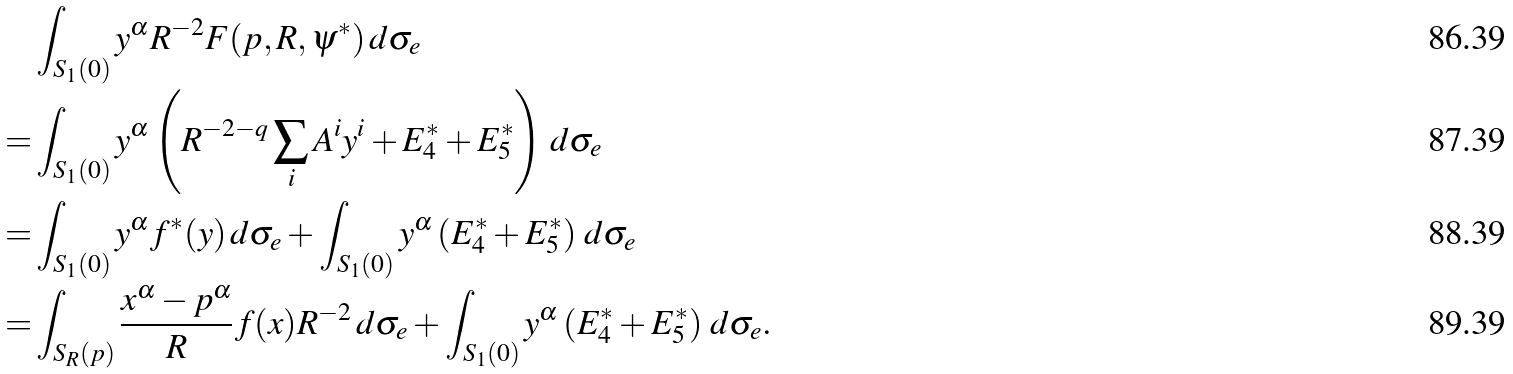<formula> <loc_0><loc_0><loc_500><loc_500>& \int _ { S _ { 1 } ( 0 ) } y ^ { \alpha } R ^ { - 2 } F ( p , R , \psi ^ { * } ) \, d \sigma _ { e } \\ = & \int _ { S _ { 1 } ( 0 ) } y ^ { \alpha } \left ( R ^ { - 2 - q } \sum _ { i } A ^ { i } y ^ { i } + E ^ { * } _ { 4 } + E _ { 5 } ^ { * } \right ) \, d \sigma _ { e } \\ = & \int _ { S _ { 1 } ( 0 ) } y ^ { \alpha } f ^ { * } ( y ) \, d \sigma _ { e } + \int _ { S _ { 1 } ( 0 ) } y ^ { \alpha } \left ( E ^ { * } _ { 4 } + E _ { 5 } ^ { * } \right ) \, d \sigma _ { e } \\ = & \int _ { S _ { R } ( p ) } \frac { x ^ { \alpha } - p ^ { \alpha } } { R } f ( x ) R ^ { - 2 } \, d \sigma _ { e } + \int _ { S _ { 1 } ( 0 ) } y ^ { \alpha } \left ( E ^ { * } _ { 4 } + E _ { 5 } ^ { * } \right ) \, d \sigma _ { e } .</formula> 